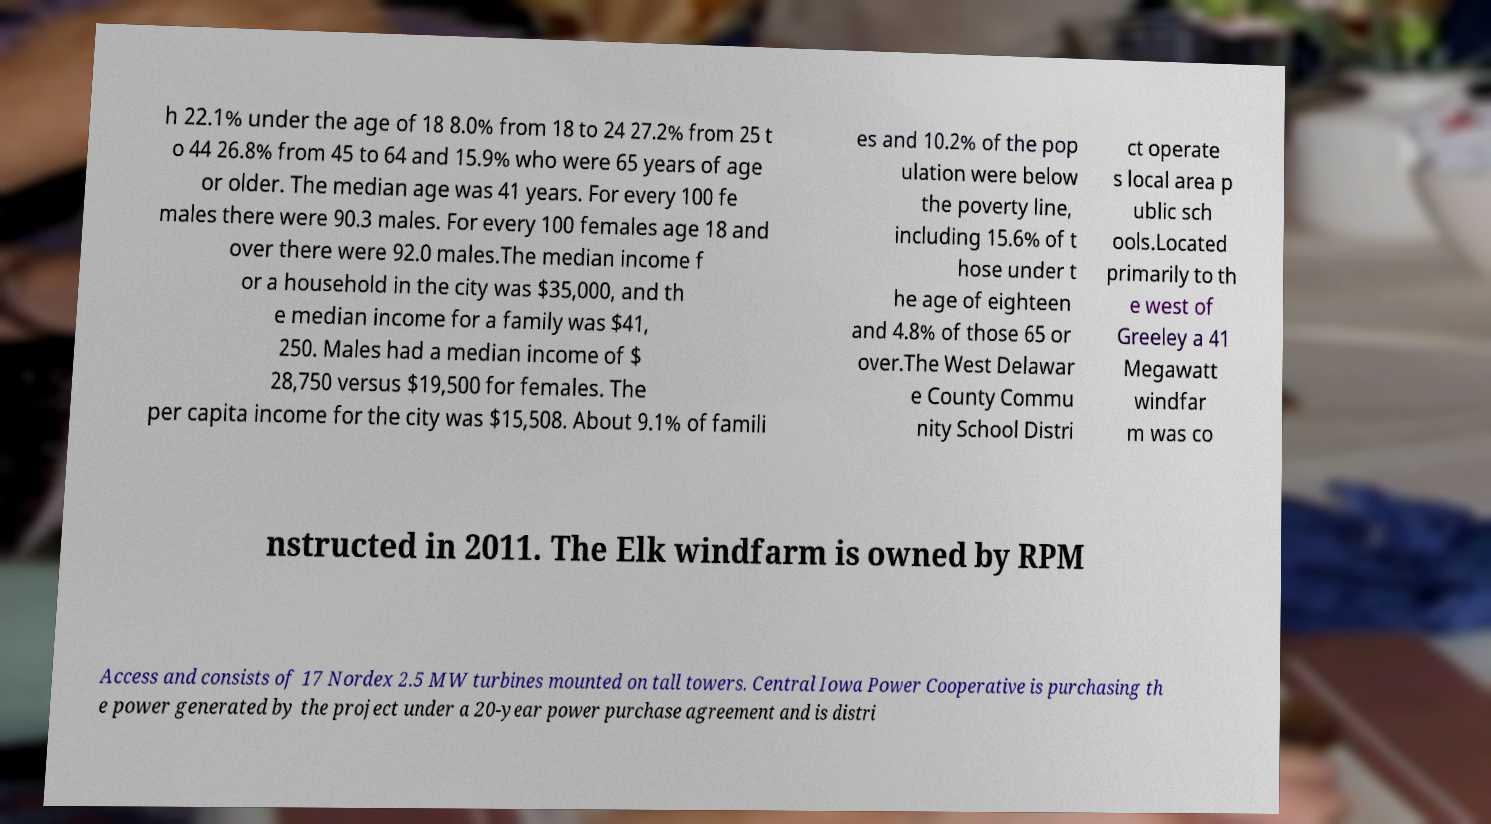For documentation purposes, I need the text within this image transcribed. Could you provide that? h 22.1% under the age of 18 8.0% from 18 to 24 27.2% from 25 t o 44 26.8% from 45 to 64 and 15.9% who were 65 years of age or older. The median age was 41 years. For every 100 fe males there were 90.3 males. For every 100 females age 18 and over there were 92.0 males.The median income f or a household in the city was $35,000, and th e median income for a family was $41, 250. Males had a median income of $ 28,750 versus $19,500 for females. The per capita income for the city was $15,508. About 9.1% of famili es and 10.2% of the pop ulation were below the poverty line, including 15.6% of t hose under t he age of eighteen and 4.8% of those 65 or over.The West Delawar e County Commu nity School Distri ct operate s local area p ublic sch ools.Located primarily to th e west of Greeley a 41 Megawatt windfar m was co nstructed in 2011. The Elk windfarm is owned by RPM Access and consists of 17 Nordex 2.5 MW turbines mounted on tall towers. Central Iowa Power Cooperative is purchasing th e power generated by the project under a 20-year power purchase agreement and is distri 